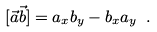<formula> <loc_0><loc_0><loc_500><loc_500>[ \vec { a } \vec { b } ] = a _ { x } b _ { y } - b _ { x } a _ { y } \ .</formula> 